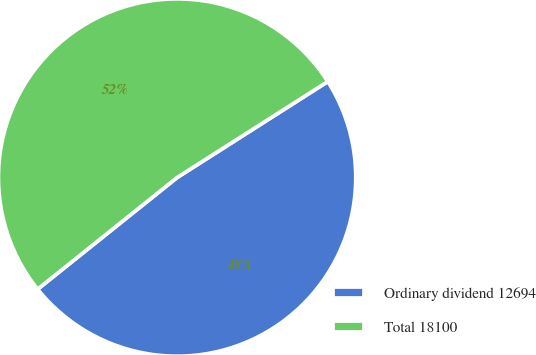Convert chart. <chart><loc_0><loc_0><loc_500><loc_500><pie_chart><fcel>Ordinary dividend 12694<fcel>Total 18100<nl><fcel>48.28%<fcel>51.72%<nl></chart> 